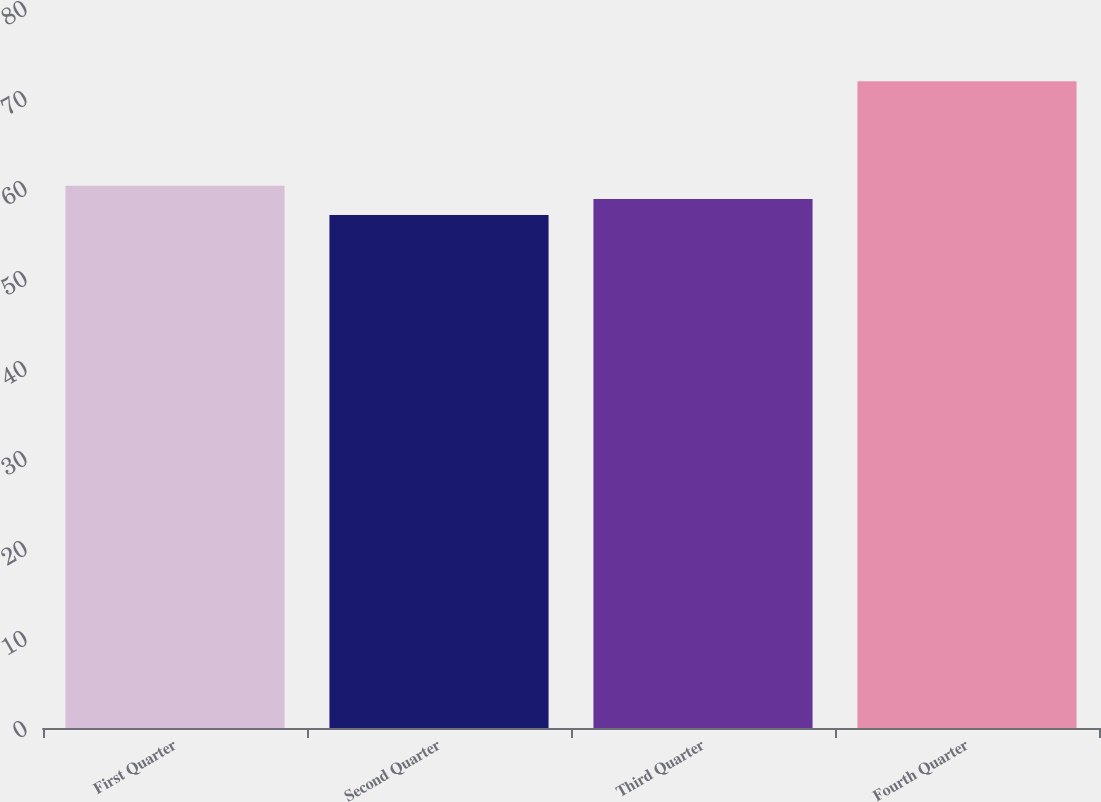Convert chart to OTSL. <chart><loc_0><loc_0><loc_500><loc_500><bar_chart><fcel>First Quarter<fcel>Second Quarter<fcel>Third Quarter<fcel>Fourth Quarter<nl><fcel>60.26<fcel>56.99<fcel>58.77<fcel>71.86<nl></chart> 